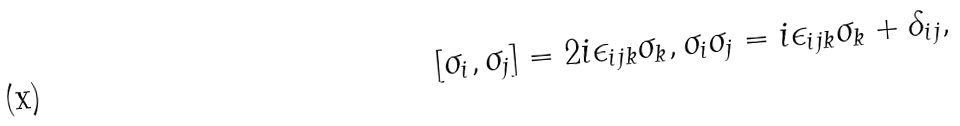<formula> <loc_0><loc_0><loc_500><loc_500>[ \sigma _ { i } , \sigma _ { j } ] = 2 i \epsilon _ { i j k } \sigma _ { k } , \sigma _ { i } \sigma _ { j } = i \epsilon _ { i j k } \sigma _ { k } + \delta _ { i j } ,</formula> 